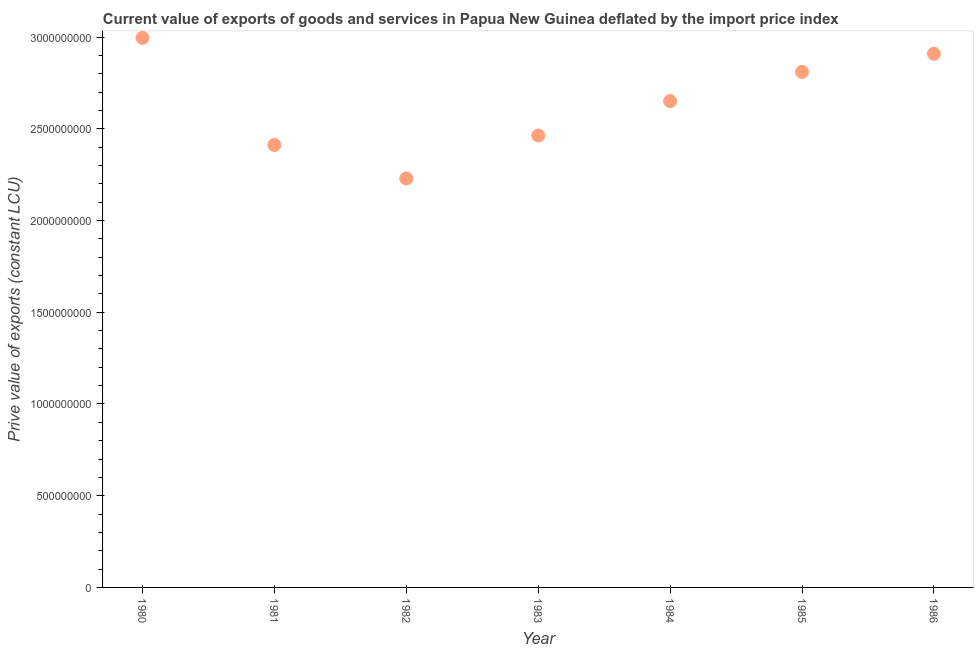What is the price value of exports in 1981?
Your answer should be compact. 2.41e+09. Across all years, what is the maximum price value of exports?
Keep it short and to the point. 3.00e+09. Across all years, what is the minimum price value of exports?
Your response must be concise. 2.23e+09. What is the sum of the price value of exports?
Provide a short and direct response. 1.85e+1. What is the difference between the price value of exports in 1981 and 1984?
Give a very brief answer. -2.39e+08. What is the average price value of exports per year?
Give a very brief answer. 2.64e+09. What is the median price value of exports?
Your answer should be very brief. 2.65e+09. In how many years, is the price value of exports greater than 2400000000 LCU?
Offer a very short reply. 6. Do a majority of the years between 1982 and 1981 (inclusive) have price value of exports greater than 1900000000 LCU?
Make the answer very short. No. What is the ratio of the price value of exports in 1983 to that in 1984?
Your answer should be very brief. 0.93. Is the difference between the price value of exports in 1983 and 1984 greater than the difference between any two years?
Your answer should be compact. No. What is the difference between the highest and the second highest price value of exports?
Offer a very short reply. 8.66e+07. What is the difference between the highest and the lowest price value of exports?
Keep it short and to the point. 7.67e+08. In how many years, is the price value of exports greater than the average price value of exports taken over all years?
Your answer should be compact. 4. What is the title of the graph?
Keep it short and to the point. Current value of exports of goods and services in Papua New Guinea deflated by the import price index. What is the label or title of the Y-axis?
Give a very brief answer. Prive value of exports (constant LCU). What is the Prive value of exports (constant LCU) in 1980?
Offer a terse response. 3.00e+09. What is the Prive value of exports (constant LCU) in 1981?
Your answer should be very brief. 2.41e+09. What is the Prive value of exports (constant LCU) in 1982?
Make the answer very short. 2.23e+09. What is the Prive value of exports (constant LCU) in 1983?
Provide a succinct answer. 2.46e+09. What is the Prive value of exports (constant LCU) in 1984?
Provide a succinct answer. 2.65e+09. What is the Prive value of exports (constant LCU) in 1985?
Your answer should be compact. 2.81e+09. What is the Prive value of exports (constant LCU) in 1986?
Give a very brief answer. 2.91e+09. What is the difference between the Prive value of exports (constant LCU) in 1980 and 1981?
Provide a succinct answer. 5.84e+08. What is the difference between the Prive value of exports (constant LCU) in 1980 and 1982?
Give a very brief answer. 7.67e+08. What is the difference between the Prive value of exports (constant LCU) in 1980 and 1983?
Your answer should be very brief. 5.32e+08. What is the difference between the Prive value of exports (constant LCU) in 1980 and 1984?
Provide a succinct answer. 3.45e+08. What is the difference between the Prive value of exports (constant LCU) in 1980 and 1985?
Provide a succinct answer. 1.85e+08. What is the difference between the Prive value of exports (constant LCU) in 1980 and 1986?
Offer a terse response. 8.66e+07. What is the difference between the Prive value of exports (constant LCU) in 1981 and 1982?
Your response must be concise. 1.83e+08. What is the difference between the Prive value of exports (constant LCU) in 1981 and 1983?
Offer a very short reply. -5.17e+07. What is the difference between the Prive value of exports (constant LCU) in 1981 and 1984?
Your response must be concise. -2.39e+08. What is the difference between the Prive value of exports (constant LCU) in 1981 and 1985?
Ensure brevity in your answer.  -3.99e+08. What is the difference between the Prive value of exports (constant LCU) in 1981 and 1986?
Your response must be concise. -4.97e+08. What is the difference between the Prive value of exports (constant LCU) in 1982 and 1983?
Offer a very short reply. -2.34e+08. What is the difference between the Prive value of exports (constant LCU) in 1982 and 1984?
Offer a very short reply. -4.22e+08. What is the difference between the Prive value of exports (constant LCU) in 1982 and 1985?
Provide a succinct answer. -5.81e+08. What is the difference between the Prive value of exports (constant LCU) in 1982 and 1986?
Your answer should be very brief. -6.80e+08. What is the difference between the Prive value of exports (constant LCU) in 1983 and 1984?
Provide a succinct answer. -1.88e+08. What is the difference between the Prive value of exports (constant LCU) in 1983 and 1985?
Your answer should be compact. -3.47e+08. What is the difference between the Prive value of exports (constant LCU) in 1983 and 1986?
Your answer should be very brief. -4.46e+08. What is the difference between the Prive value of exports (constant LCU) in 1984 and 1985?
Provide a succinct answer. -1.59e+08. What is the difference between the Prive value of exports (constant LCU) in 1984 and 1986?
Your answer should be compact. -2.58e+08. What is the difference between the Prive value of exports (constant LCU) in 1985 and 1986?
Your answer should be compact. -9.88e+07. What is the ratio of the Prive value of exports (constant LCU) in 1980 to that in 1981?
Keep it short and to the point. 1.24. What is the ratio of the Prive value of exports (constant LCU) in 1980 to that in 1982?
Your response must be concise. 1.34. What is the ratio of the Prive value of exports (constant LCU) in 1980 to that in 1983?
Your answer should be very brief. 1.22. What is the ratio of the Prive value of exports (constant LCU) in 1980 to that in 1984?
Provide a succinct answer. 1.13. What is the ratio of the Prive value of exports (constant LCU) in 1980 to that in 1985?
Keep it short and to the point. 1.07. What is the ratio of the Prive value of exports (constant LCU) in 1981 to that in 1982?
Make the answer very short. 1.08. What is the ratio of the Prive value of exports (constant LCU) in 1981 to that in 1984?
Provide a short and direct response. 0.91. What is the ratio of the Prive value of exports (constant LCU) in 1981 to that in 1985?
Give a very brief answer. 0.86. What is the ratio of the Prive value of exports (constant LCU) in 1981 to that in 1986?
Provide a short and direct response. 0.83. What is the ratio of the Prive value of exports (constant LCU) in 1982 to that in 1983?
Offer a terse response. 0.91. What is the ratio of the Prive value of exports (constant LCU) in 1982 to that in 1984?
Ensure brevity in your answer.  0.84. What is the ratio of the Prive value of exports (constant LCU) in 1982 to that in 1985?
Your answer should be compact. 0.79. What is the ratio of the Prive value of exports (constant LCU) in 1982 to that in 1986?
Keep it short and to the point. 0.77. What is the ratio of the Prive value of exports (constant LCU) in 1983 to that in 1984?
Make the answer very short. 0.93. What is the ratio of the Prive value of exports (constant LCU) in 1983 to that in 1985?
Ensure brevity in your answer.  0.88. What is the ratio of the Prive value of exports (constant LCU) in 1983 to that in 1986?
Offer a very short reply. 0.85. What is the ratio of the Prive value of exports (constant LCU) in 1984 to that in 1985?
Give a very brief answer. 0.94. What is the ratio of the Prive value of exports (constant LCU) in 1984 to that in 1986?
Offer a terse response. 0.91. 